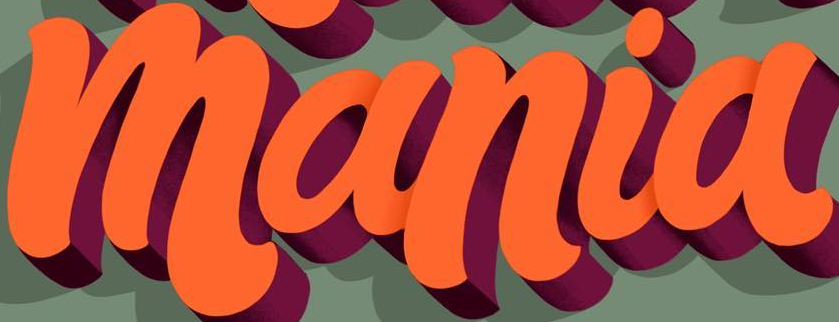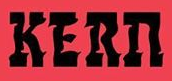Read the text from these images in sequence, separated by a semicolon. mania; KERn 